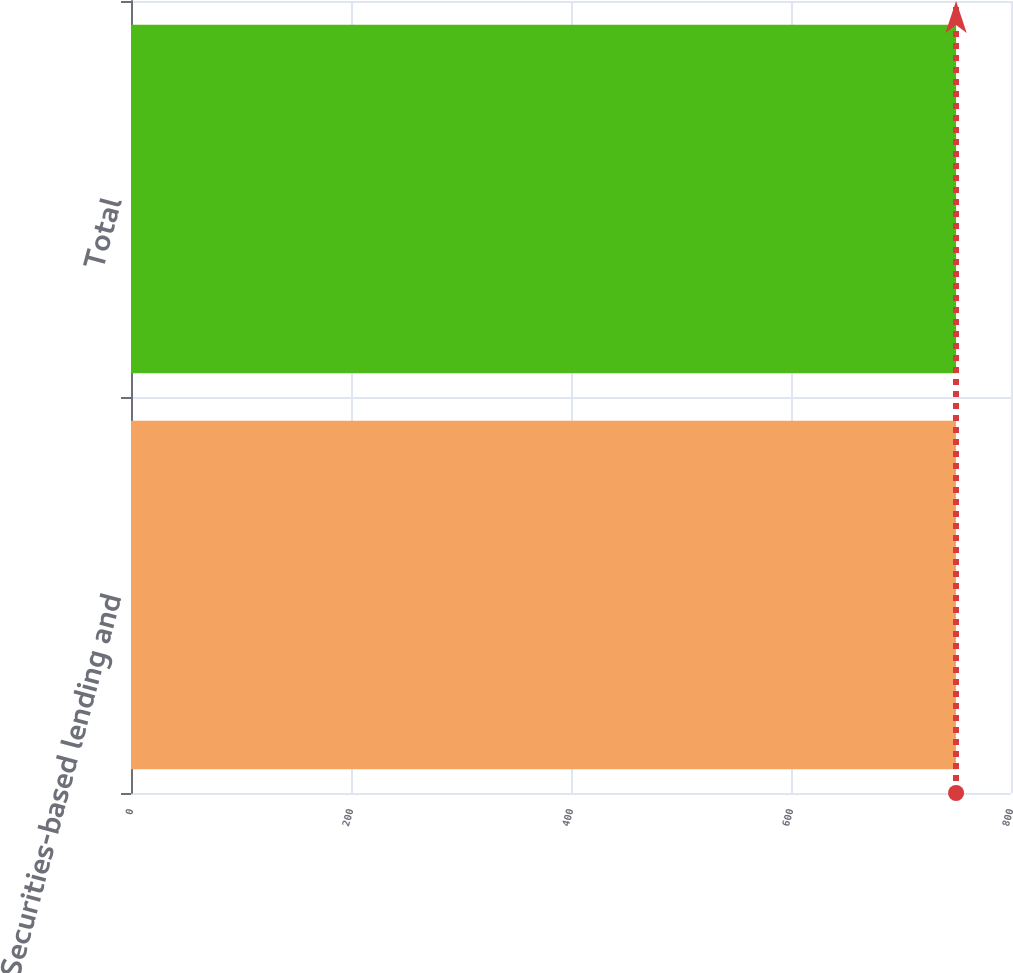Convert chart to OTSL. <chart><loc_0><loc_0><loc_500><loc_500><bar_chart><fcel>Securities-based lending and<fcel>Total<nl><fcel>750<fcel>750.1<nl></chart> 